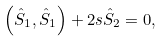Convert formula to latex. <formula><loc_0><loc_0><loc_500><loc_500>\left ( \hat { S } _ { 1 } , \hat { S } _ { 1 } \right ) + 2 s \hat { S } _ { 2 } = 0 ,</formula> 